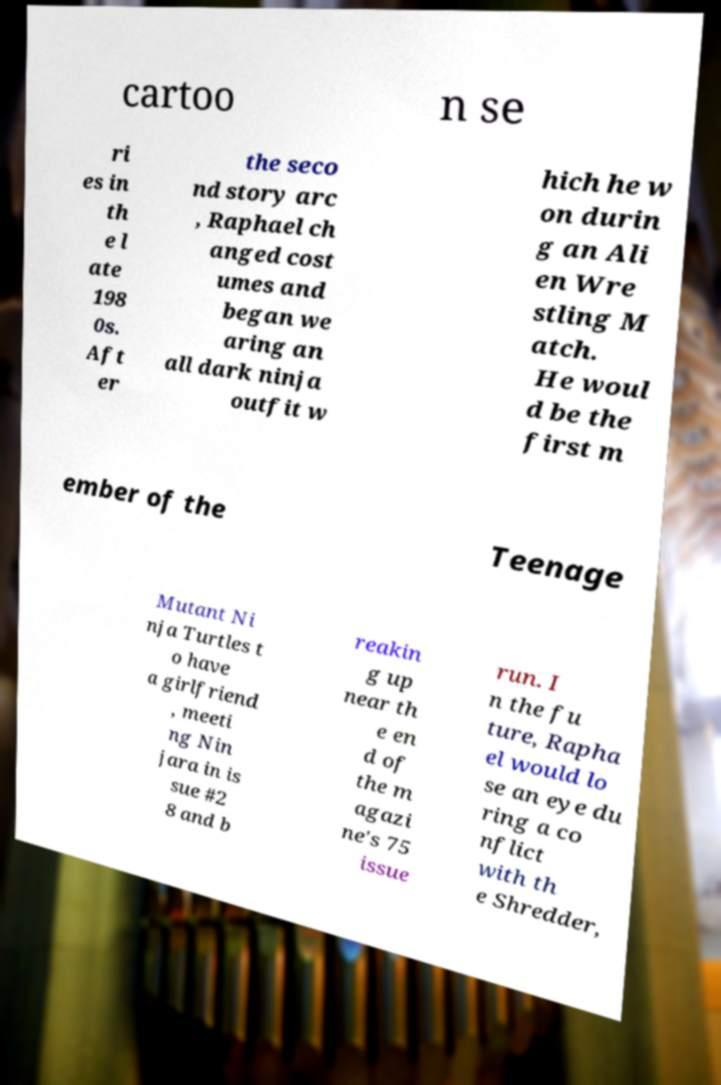Could you assist in decoding the text presented in this image and type it out clearly? cartoo n se ri es in th e l ate 198 0s. Aft er the seco nd story arc , Raphael ch anged cost umes and began we aring an all dark ninja outfit w hich he w on durin g an Ali en Wre stling M atch. He woul d be the first m ember of the Teenage Mutant Ni nja Turtles t o have a girlfriend , meeti ng Nin jara in is sue #2 8 and b reakin g up near th e en d of the m agazi ne's 75 issue run. I n the fu ture, Rapha el would lo se an eye du ring a co nflict with th e Shredder, 